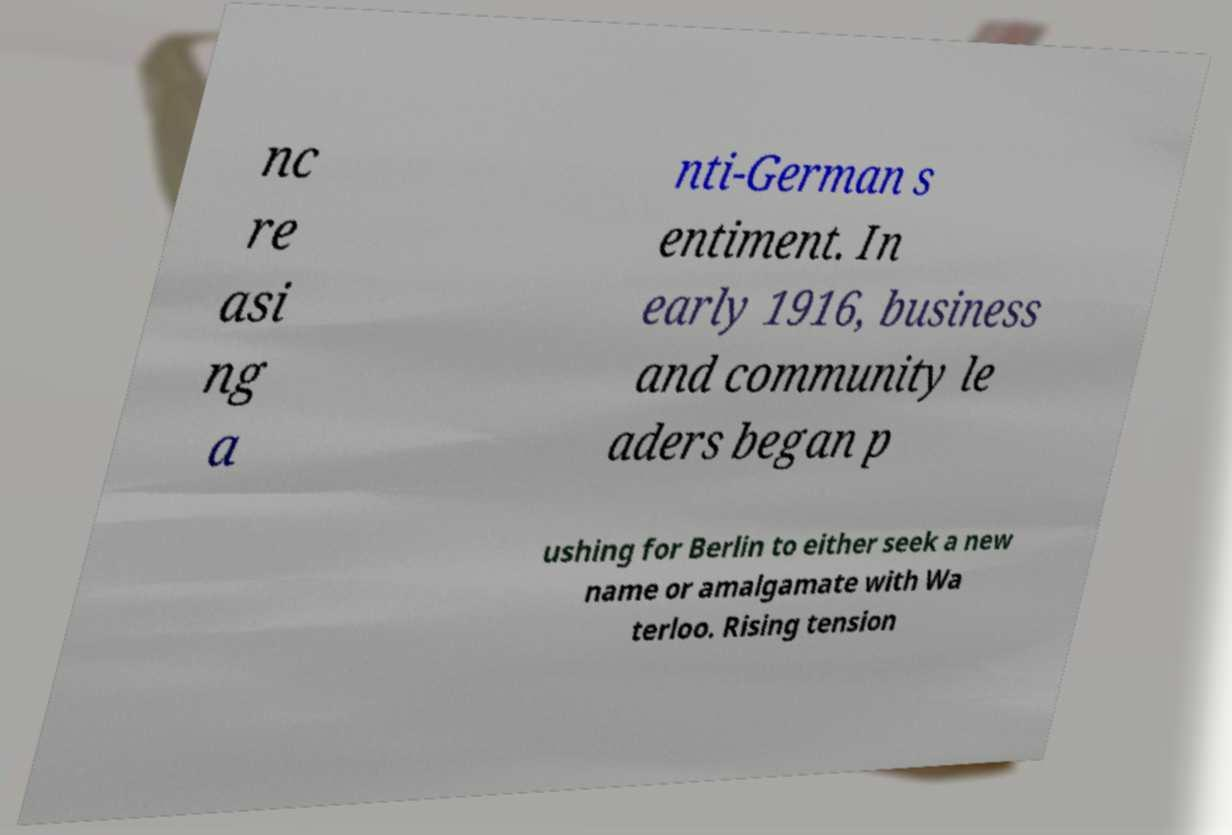I need the written content from this picture converted into text. Can you do that? nc re asi ng a nti-German s entiment. In early 1916, business and community le aders began p ushing for Berlin to either seek a new name or amalgamate with Wa terloo. Rising tension 